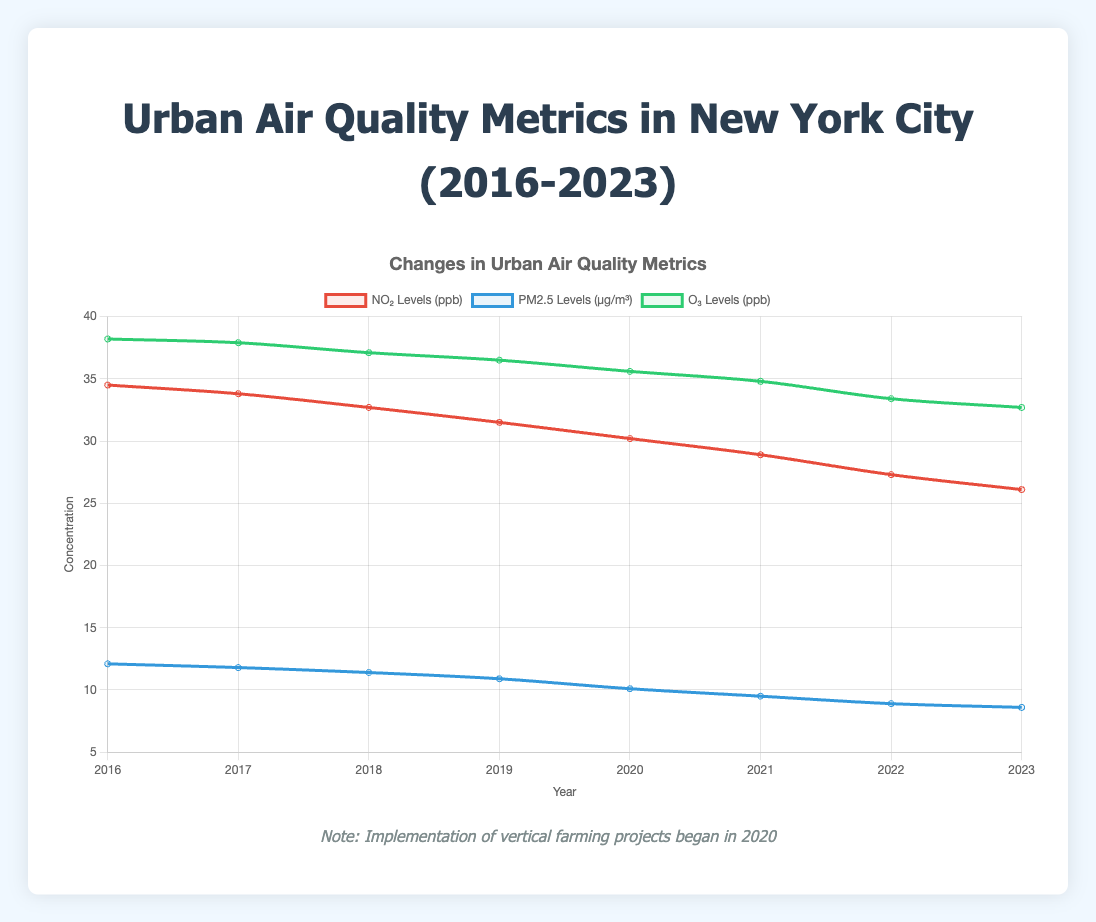What year did the implementation of vertical farming projects begin? The vertical farming implementation began in 2020, as indicated by the annotation line labeled "Vertical Farming Implementation."
Answer: 2020 How did NO₂ levels change from 2019 to 2020? In 2019, the NO₂ levels were 31.5 ppb, and in 2020, they were 30.2 ppb. The levels decreased by 31.5 - 30.2 = 1.3 ppb.
Answer: Decreased by 1.3 ppb Compare the PM2.5 levels in 2016 and 2023. Which year had lower levels? In 2016, the PM2.5 levels were 12.1 µg/m³, and in 2023, they were 8.6 µg/m³. 2023 had lower levels.
Answer: 2023 What is the average O₃ level from 2016 to 2023? The O₃ levels from 2016 to 2023 are: 38.2, 37.9, 37.1, 36.5, 35.6, 34.8, 33.4, 32.7. The sum is 286.2. The average is 286.2 / 8 = 35.775 ppb.
Answer: 35.775 ppb Which pollutant showed the greatest absolute reduction from 2016 to 2023? NO₂ decreased from 34.5 to 26.1 (8.4 ppb reduction), PM2.5 decreased from 12.1 to 8.6 (3.5 µg/m³ reduction), and O₃ decreased from 38.2 to 32.7 (5.5 ppb reduction). The greatest absolute reduction is in NO₂ levels.
Answer: NO₂ Compare the trend of PM2.5 and O₃ levels post-2020. How do they differ? After 2020, PM2.5 levels decrease from 10.1 µg/m³ to 8.6 µg/m³ by 2023, while O₃ levels decrease from 35.6 ppb to 32.7 ppb by 2023. Both decrease, but PM2.5 levels decrease more steeply.
Answer: PM2.5 decreases more steeply What was the difference in O₃ levels between 2017 and 2019? In 2017, the O₃ levels were 37.9 ppb, and in 2019, they were 36.5 ppb. The difference is 37.9 - 36.5 = 1.4 ppb.
Answer: 1.4 ppb What is the overall trend in NO₂ levels from 2016 to 2023? NO₂ levels show a continuous decreasing trend from 34.5 ppb in 2016 to 26.1 ppb in 2023.
Answer: Decreasing trend By how much did PM2.5 levels decrease in the year immediately following the implementation of vertical farming? From 2020 to 2021, PM2.5 levels decreased from 10.1 µg/m³ to 9.5 µg/m³. The decrease is 10.1 - 9.5 = 0.6 µg/m³.
Answer: 0.6 µg/m³ 